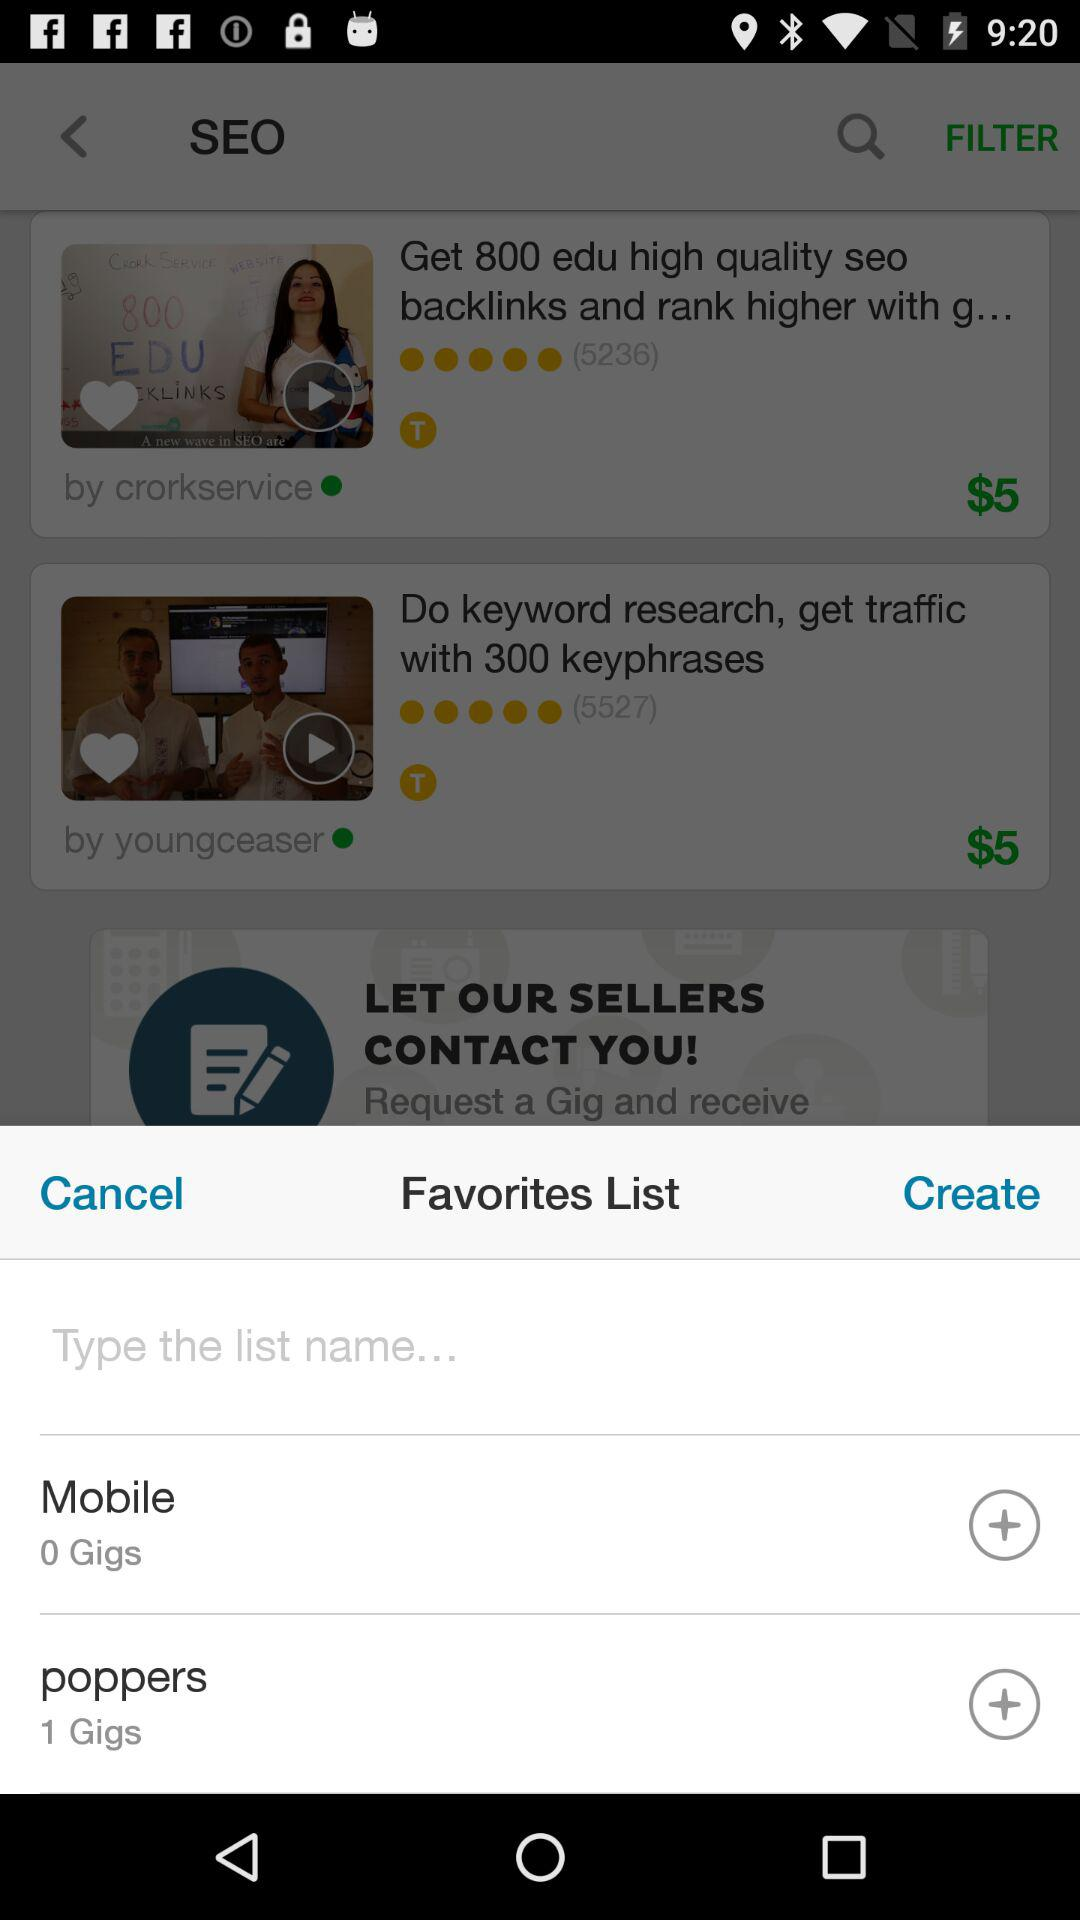What is the number of gigs in "poppers"? The number of gigs in "poppers" is 1. 